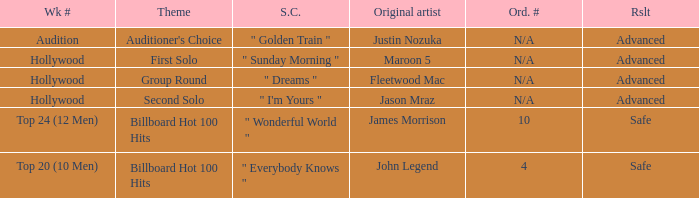What are all of the order # where authentic artist is maroon 5 N/A. 